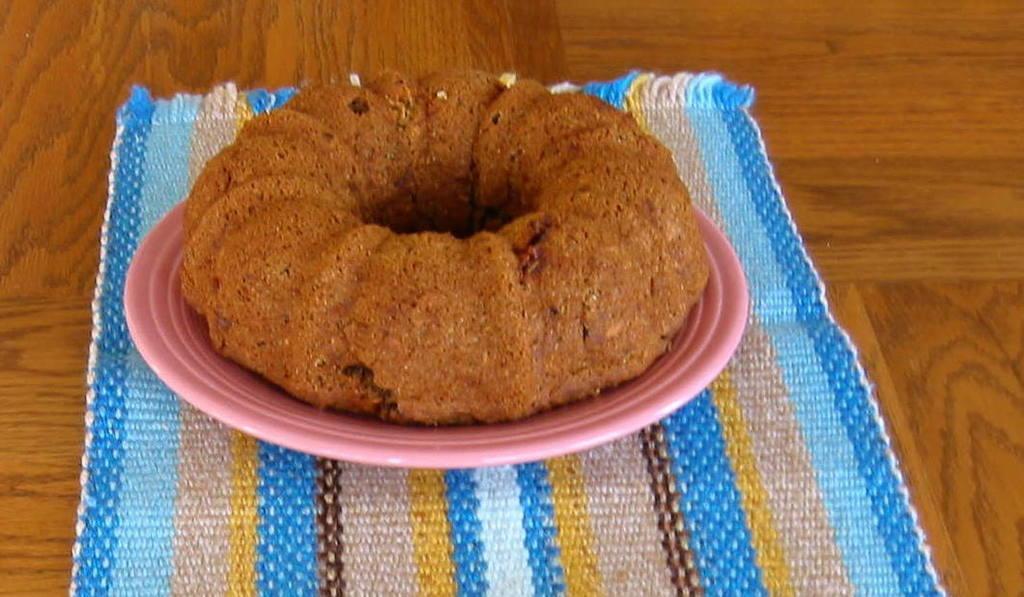Could you give a brief overview of what you see in this image? In this image I can see food in a pink colour plate. I can also see a cloth of different colours. 